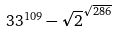<formula> <loc_0><loc_0><loc_500><loc_500>3 3 ^ { 1 0 9 } - \sqrt { 2 } ^ { \sqrt { 2 8 6 } }</formula> 